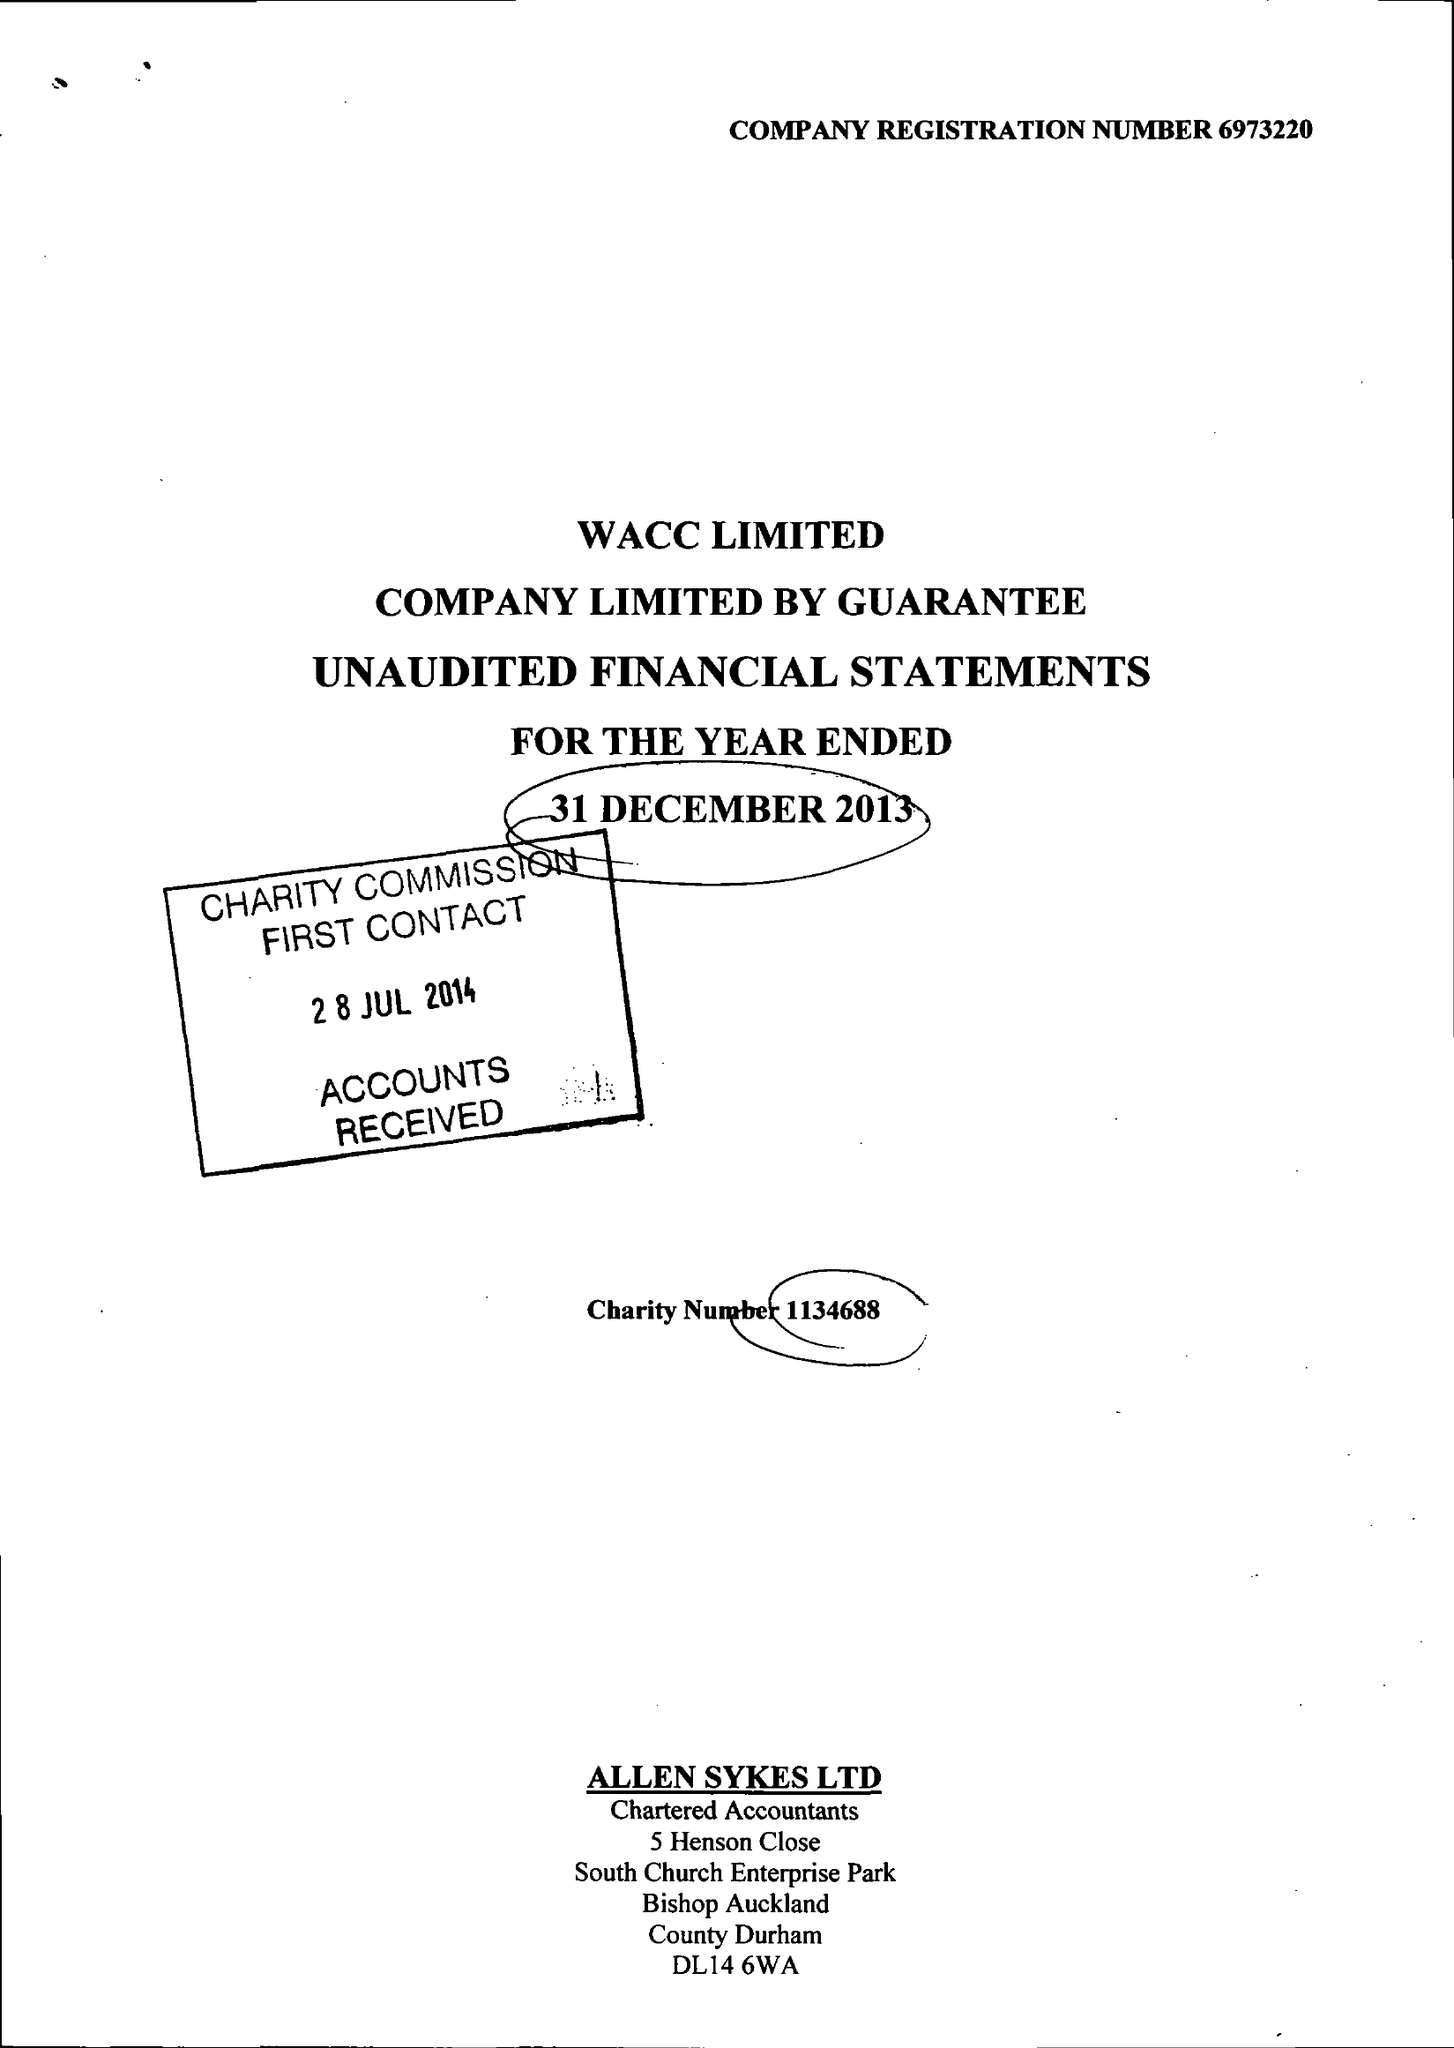What is the value for the spending_annually_in_british_pounds?
Answer the question using a single word or phrase. 52228.00 